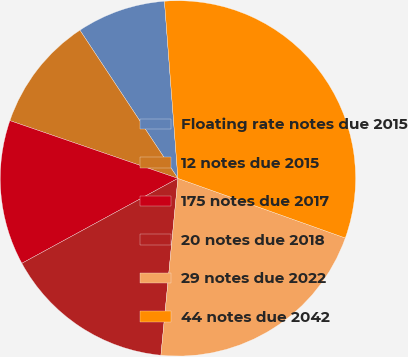Convert chart to OTSL. <chart><loc_0><loc_0><loc_500><loc_500><pie_chart><fcel>Floating rate notes due 2015<fcel>12 notes due 2015<fcel>175 notes due 2017<fcel>20 notes due 2018<fcel>29 notes due 2022<fcel>44 notes due 2042<nl><fcel>8.09%<fcel>10.43%<fcel>13.2%<fcel>15.54%<fcel>21.08%<fcel>31.65%<nl></chart> 